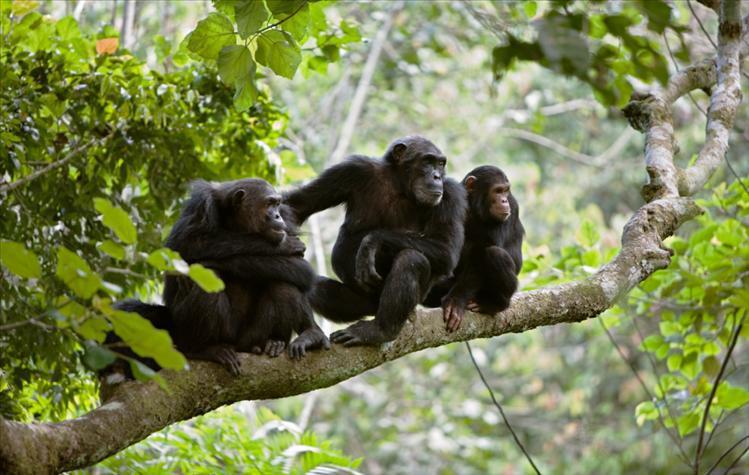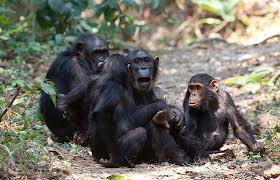The first image is the image on the left, the second image is the image on the right. Assess this claim about the two images: "At least one of the chimps has their feet in water.". Correct or not? Answer yes or no. No. The first image is the image on the left, the second image is the image on the right. Considering the images on both sides, is "The left image contains one left-facing chimp, and the right image features an ape splashing in water." valid? Answer yes or no. No. 